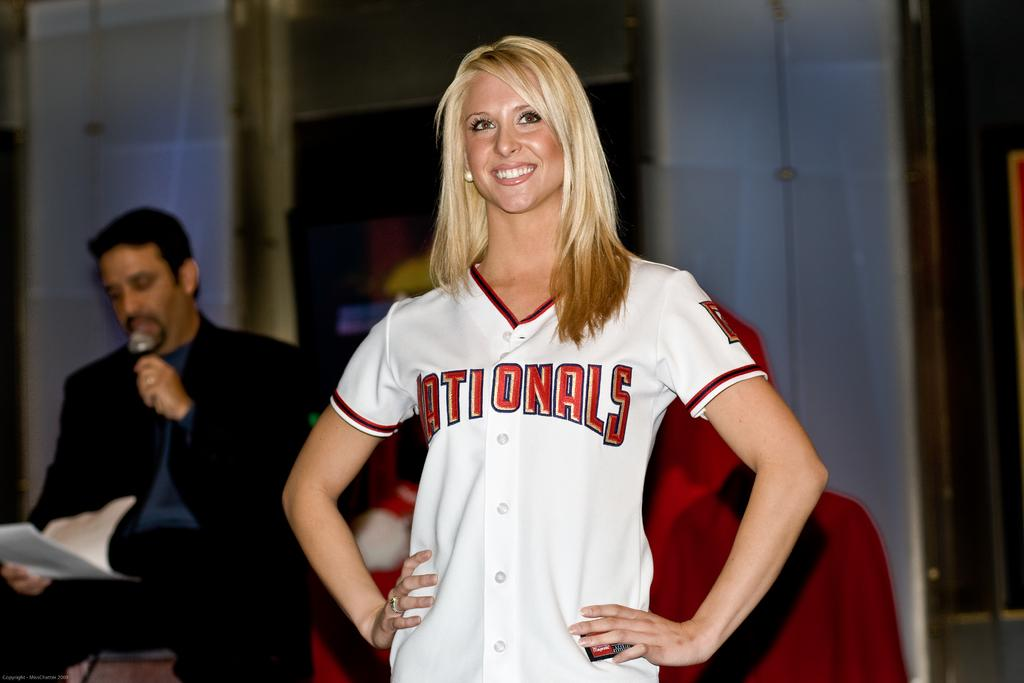Provide a one-sentence caption for the provided image. A blonde woman wears a jersey bearing the name Nationals. 